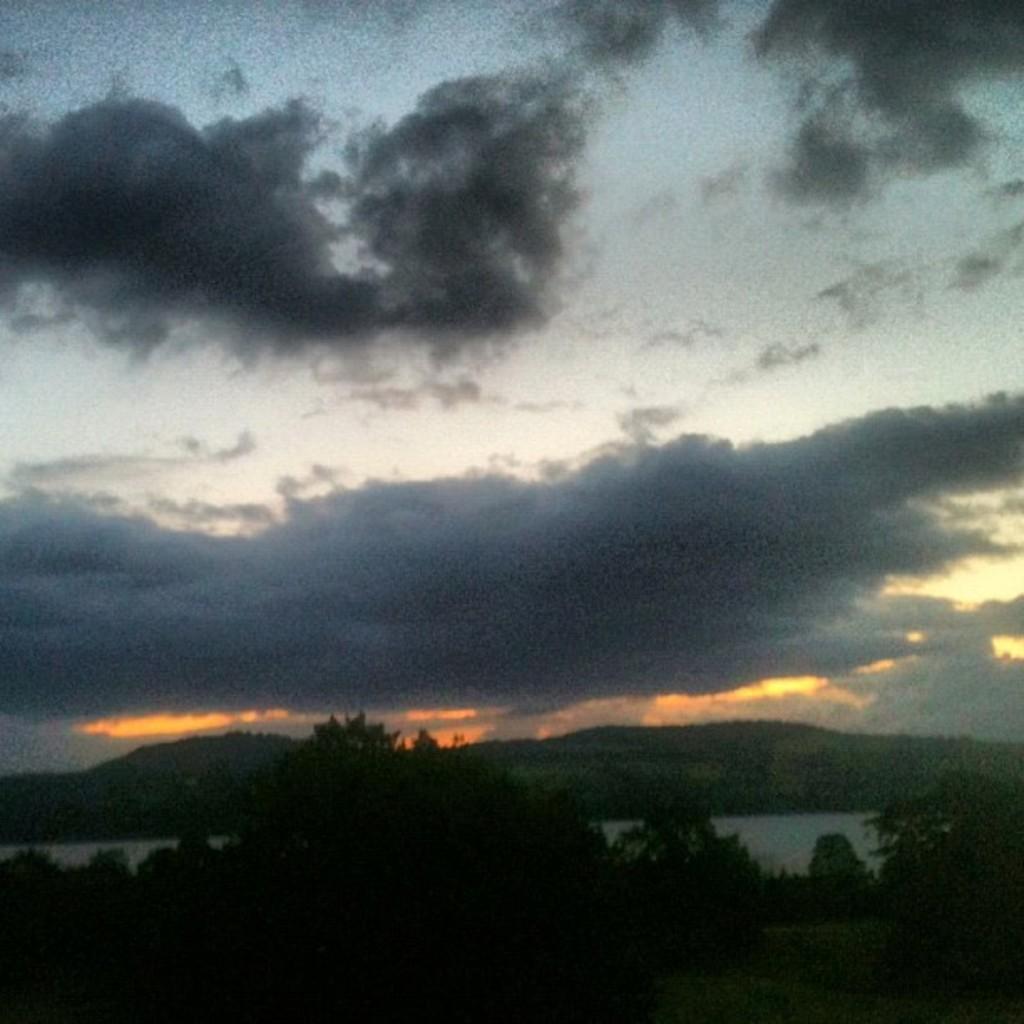Could you give a brief overview of what you see in this image? In the picture I can see trees, lake and clouded sky. 